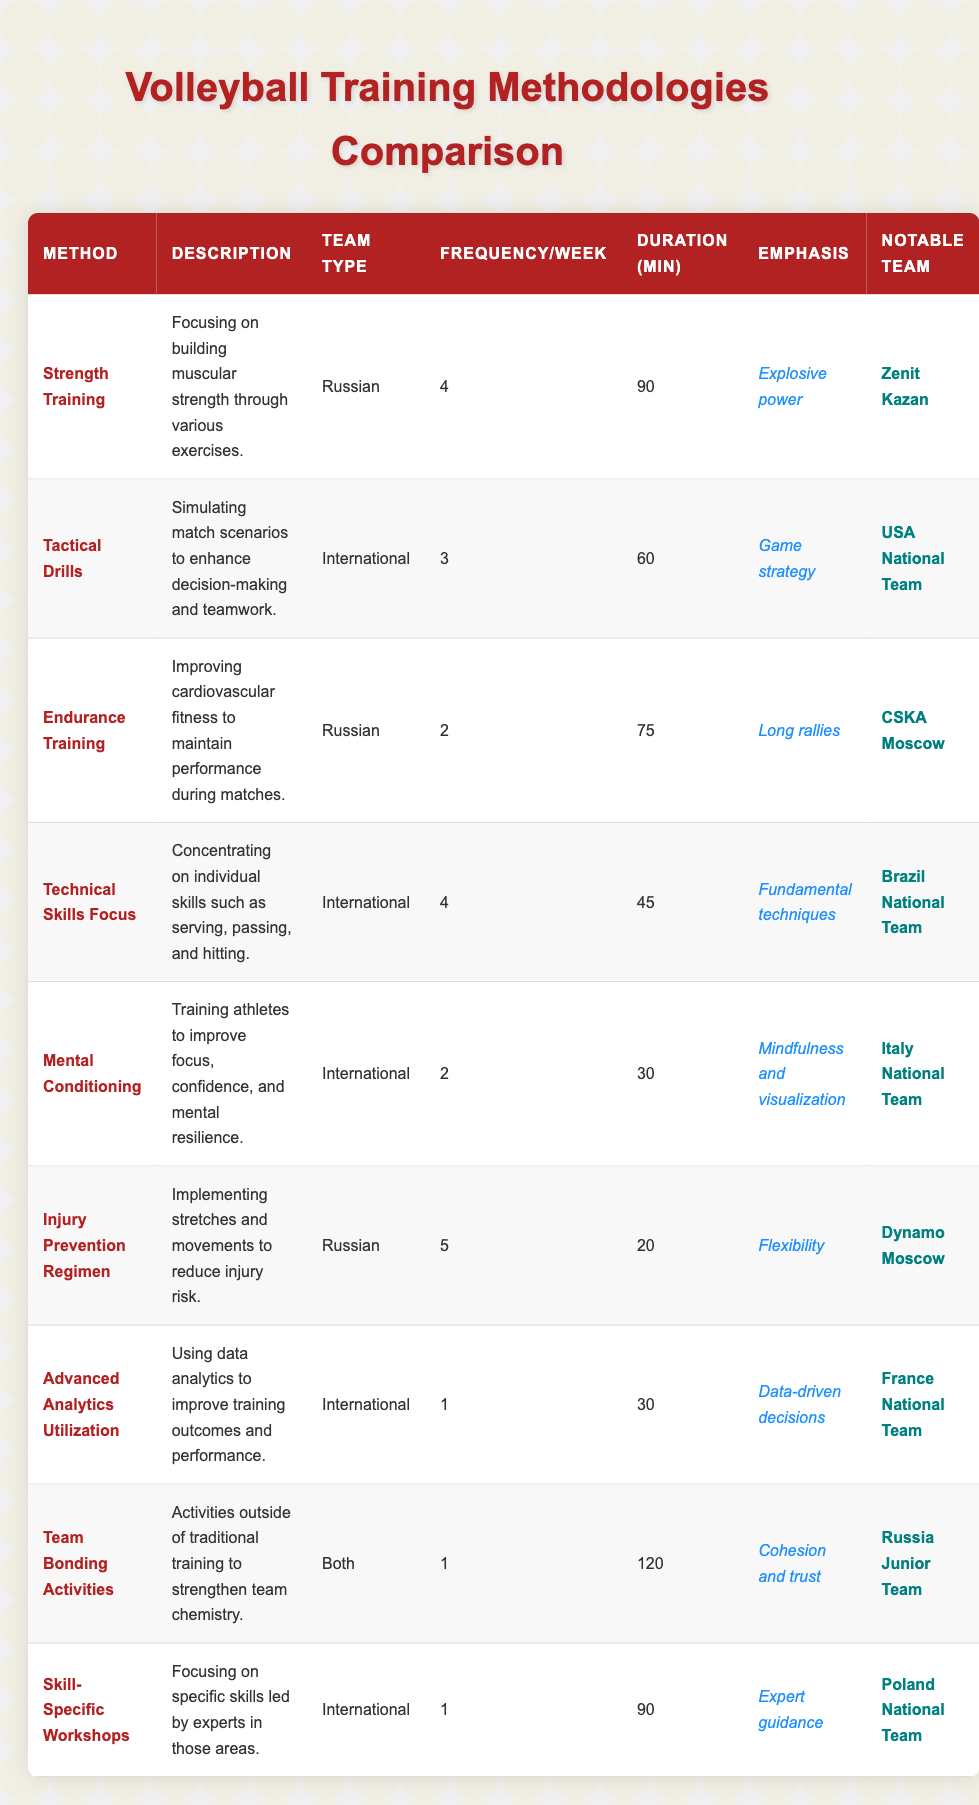What is the training frequency for Injury Prevention Regimen by Russian teams? The table shows that the "Injury Prevention Regimen" for Russian teams has a training frequency of 5 times per week.
Answer: 5 Which training methodology has the shortest duration per session for International teams? According to the table, "Mental Conditioning" has the shortest duration per session at 30 minutes for International teams.
Answer: 30 minutes How many methodologies have a frequency of 4 times per week? From the table, there are two methodologies that have a frequency of 4 times per week: "Strength Training" (Russian) and "Technical Skills Focus" (International).
Answer: 2 Is Endurance Training a focus for International teams? The table indicates that "Endurance Training" is listed under Russian teams, not under International teams, so this statement is false.
Answer: No What is the total duration of training sessions per week for the "Strength Training" methodology? "Strength Training" is conducted 4 times a week with each session lasting 90 minutes, so the total duration is 4 * 90 = 360 minutes per week.
Answer: 360 minutes Which notable team uses Tactical Drills, and what is their training emphasis? The table shows that "Tactical Drills" is utilized by the "USA National Team," with the emphasis on "Game strategy."
Answer: USA National Team, Game strategy What is the average training duration across all methodologies for Russian teams? The training durations for Russian teams are 90, 75, and 20 minutes. Their average is calculated as (90 + 75 + 20) / 3 = 185 / 3 = 61.67 minutes.
Answer: 61.67 minutes Which methodology is practiced only by both Russian and International teams, and how often? The table indicates that "Team Bonding Activities" is practiced by both Russian and International teams, with a frequency of 1 time per week.
Answer: Team Bonding Activities, 1 time per week How does the frequency of Technical Skills Focus compare to that of Mental Conditioning? The table shows that "Technical Skills Focus" has a frequency of 4 times per week, while "Mental Conditioning" has a frequency of 2 times per week. This means Technical Skills Focus is practiced more frequently.
Answer: Technical Skills Focus is more frequent Which methodology for International teams focuses on data analytics, and what is its frequency? The methodology "Advanced Analytics Utilization" focuses on data analytics for International teams, with a frequency of 1 time per week.
Answer: Advanced Analytics Utilization, 1 time per week 